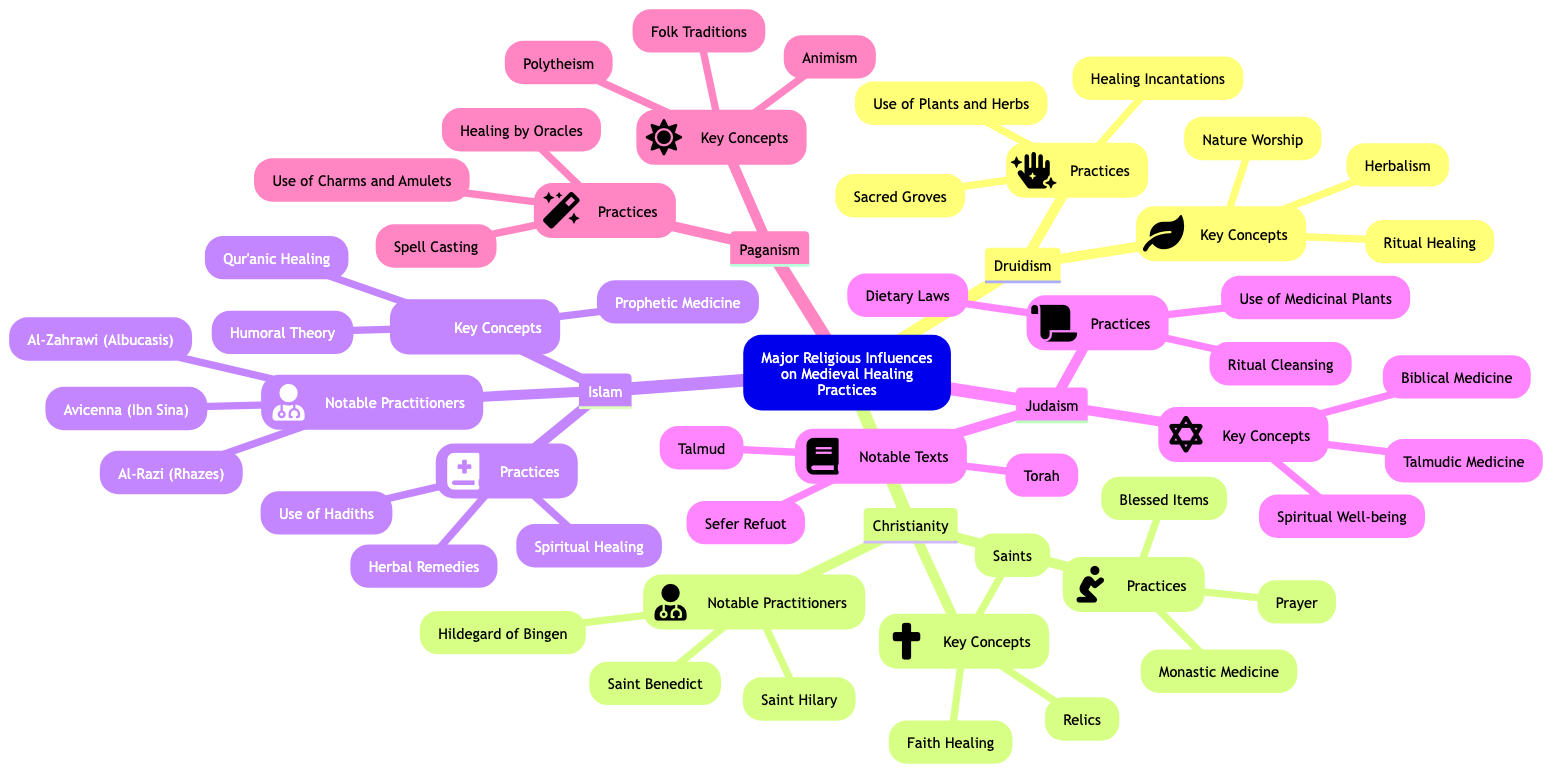What are the key concepts of Druidism? The diagram shows that the key concepts of Druidism include Nature Worship, Herbalism, and Ritual Healing listed under the Druidism section.
Answer: Nature Worship, Herbalism, Ritual Healing How many notable practitioners are listed for Christianity? There are three notable practitioners mentioned under the Christianity section in the mind map: Hildegard of Bingen, Saint Benedict, and Saint Hilary.
Answer: 3 What practices are associated with Islam? The Islam section lists three practices: Use of Hadiths, Herbal Remedies, and Spiritual Healing.
Answer: Use of Hadiths, Herbal Remedies, Spiritual Healing What religious influence includes the practice of spell casting? The Paganism section of the mind map specifies spell casting as one of its practices.
Answer: Paganism What is one of the notable texts in Judaism? The Judaism section points to three notable texts, one of which is the Talmud explicitly mentioned as a notable text.
Answer: Talmud Which religious influence emphasizes faith healing? Christianity is highlighted in the diagram under the Key Concepts as emphasizing faith healing.
Answer: Christianity List two key concepts associated with Judaism. The key concepts listed in the Judaism section are Biblical Medicine, Talmudic Medicine, and Spiritual Well-being. Two of them can be taken: Biblical Medicine and Talmudic Medicine.
Answer: Biblical Medicine, Talmudic Medicine What practices are tied to Druidism? The practices associated with Druidism include Sacred Groves, Use of Plants and Herbs, and Healing Incantations as shown in the Druidism section.
Answer: Sacred Groves, Use of Plants and Herbs, Healing Incantations 